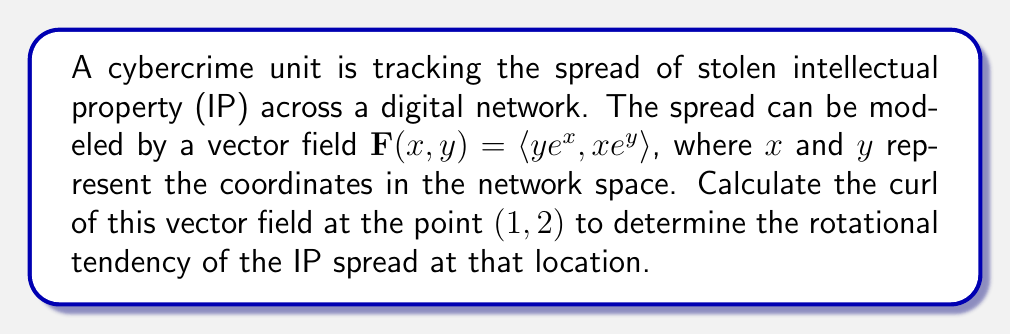Can you solve this math problem? To solve this problem, we need to calculate the curl of the given vector field at the specified point. Let's break it down step-by-step:

1) The curl of a vector field $\mathbf{F}(x, y) = \langle P, Q \rangle$ in two dimensions is defined as:

   $$\text{curl }\mathbf{F} = \frac{\partial Q}{\partial x} - \frac{\partial P}{\partial y}$$

2) In our case, $\mathbf{F}(x, y) = \langle ye^x, xe^y \rangle$, so:
   $P = ye^x$ and $Q = xe^y$

3) Let's calculate the partial derivatives:

   $\frac{\partial Q}{\partial x} = e^y$

   $\frac{\partial P}{\partial y} = e^x$

4) Now we can compute the curl:

   $$\text{curl }\mathbf{F} = \frac{\partial Q}{\partial x} - \frac{\partial P}{\partial y} = e^y - e^x$$

5) We need to evaluate this at the point $(1, 2)$:

   $$\text{curl }\mathbf{F}(1, 2) = e^2 - e^1$$

6) Simplify:
   $$e^2 - e^1 \approx 7.389 - 2.718 \approx 4.671$$

The positive curl indicates a counterclockwise rotational tendency of the IP spread at the point (1, 2) in the network space.
Answer: The curl of the vector field at the point (1, 2) is approximately 4.671. 